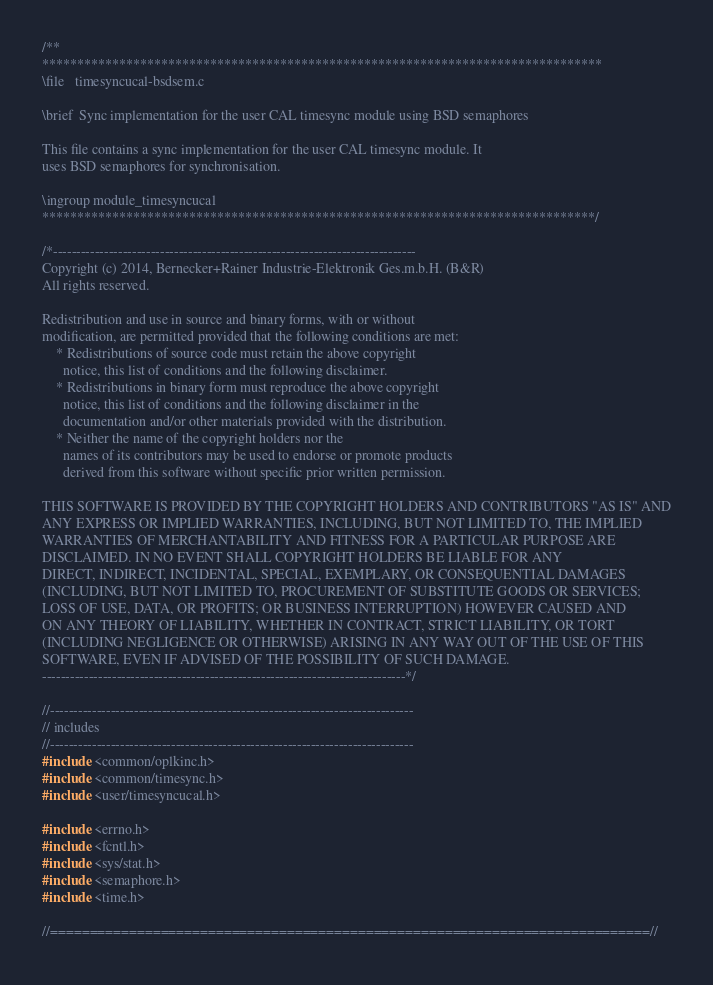<code> <loc_0><loc_0><loc_500><loc_500><_C_>/**
********************************************************************************
\file   timesyncucal-bsdsem.c

\brief  Sync implementation for the user CAL timesync module using BSD semaphores

This file contains a sync implementation for the user CAL timesync module. It
uses BSD semaphores for synchronisation.

\ingroup module_timesyncucal
*******************************************************************************/

/*------------------------------------------------------------------------------
Copyright (c) 2014, Bernecker+Rainer Industrie-Elektronik Ges.m.b.H. (B&R)
All rights reserved.

Redistribution and use in source and binary forms, with or without
modification, are permitted provided that the following conditions are met:
    * Redistributions of source code must retain the above copyright
      notice, this list of conditions and the following disclaimer.
    * Redistributions in binary form must reproduce the above copyright
      notice, this list of conditions and the following disclaimer in the
      documentation and/or other materials provided with the distribution.
    * Neither the name of the copyright holders nor the
      names of its contributors may be used to endorse or promote products
      derived from this software without specific prior written permission.

THIS SOFTWARE IS PROVIDED BY THE COPYRIGHT HOLDERS AND CONTRIBUTORS "AS IS" AND
ANY EXPRESS OR IMPLIED WARRANTIES, INCLUDING, BUT NOT LIMITED TO, THE IMPLIED
WARRANTIES OF MERCHANTABILITY AND FITNESS FOR A PARTICULAR PURPOSE ARE
DISCLAIMED. IN NO EVENT SHALL COPYRIGHT HOLDERS BE LIABLE FOR ANY
DIRECT, INDIRECT, INCIDENTAL, SPECIAL, EXEMPLARY, OR CONSEQUENTIAL DAMAGES
(INCLUDING, BUT NOT LIMITED TO, PROCUREMENT OF SUBSTITUTE GOODS OR SERVICES;
LOSS OF USE, DATA, OR PROFITS; OR BUSINESS INTERRUPTION) HOWEVER CAUSED AND
ON ANY THEORY OF LIABILITY, WHETHER IN CONTRACT, STRICT LIABILITY, OR TORT
(INCLUDING NEGLIGENCE OR OTHERWISE) ARISING IN ANY WAY OUT OF THE USE OF THIS
SOFTWARE, EVEN IF ADVISED OF THE POSSIBILITY OF SUCH DAMAGE.
------------------------------------------------------------------------------*/

//------------------------------------------------------------------------------
// includes
//------------------------------------------------------------------------------
#include <common/oplkinc.h>
#include <common/timesync.h>
#include <user/timesyncucal.h>

#include <errno.h>
#include <fcntl.h>
#include <sys/stat.h>
#include <semaphore.h>
#include <time.h>

//============================================================================//</code> 